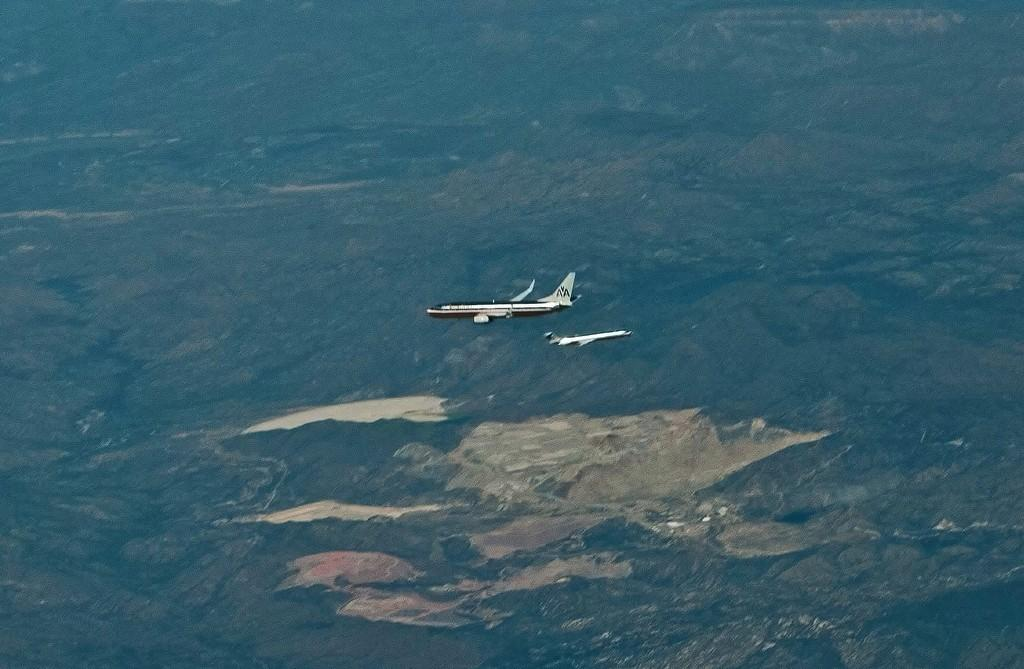How many airplanes are visible in the image? There are two airplanes in the image. Can you describe the background of the image? The background of the image appears blurred. Where is the throne located in the image? There is no throne present in the image. What type of hill can be seen in the background of the image? There is no hill visible in the image, as the background appears blurred. 